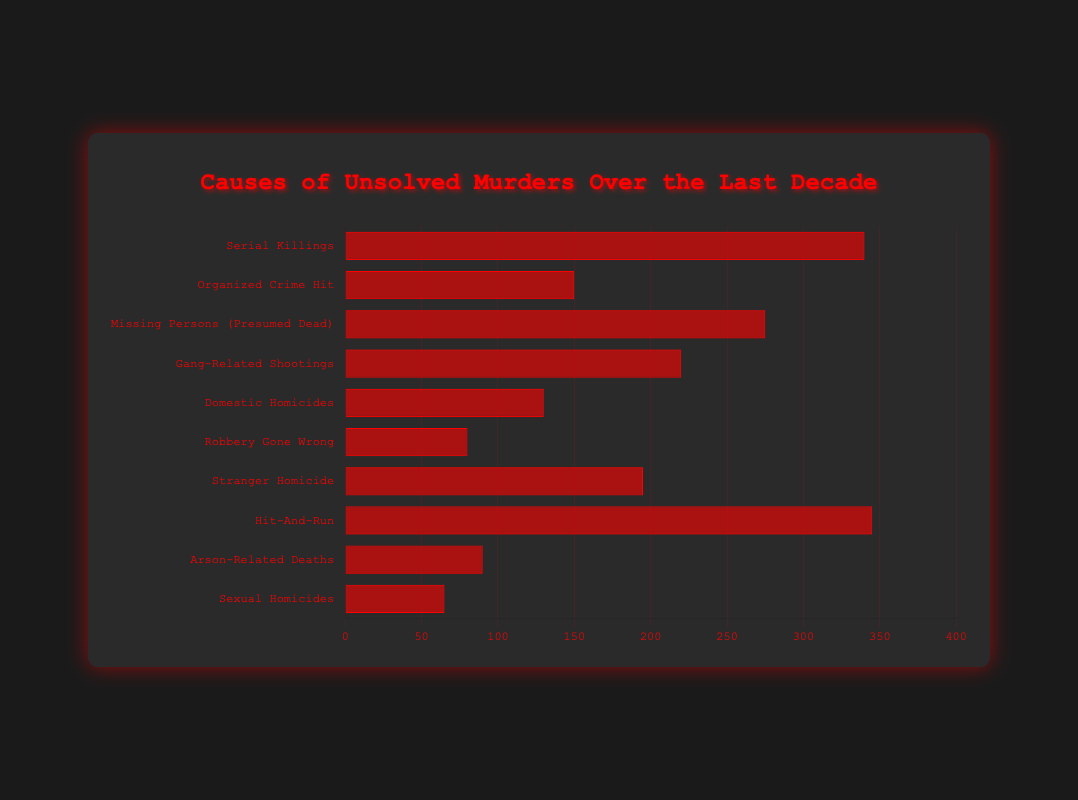What's the most common type of crime for unsolved murder cases? The longest bar in the chart corresponds to Hit-And-Run cases, and since the chart orders the crimes by the number of unsolved cases, it's easy to see that Hit-And-Run has the highest number of unsolved cases at 345.
Answer: Hit-And-Run Which type of crime has fewer unsolved cases: Gang-Related Shootings or Stranger Homicide? Comparing the lengths of the bars, Gang-Related Shootings have 220 unsolved cases, while Stranger Homicide has 195 unsolved cases. Therefore, Stranger Homicide has fewer unsolved cases.
Answer: Stranger Homicide What is the total number of unsolved cases for Organised Crime Hit and Domestic Homicides combined? Add the unsolved cases for Organised Crime Hit (150) and Domestic Homicides (130). Therefore, the total is 150 + 130 = 280.
Answer: 280 Which has a higher number of unsolved cases: Sexual Homicides or Robbery Gone Wrong? By comparing the bars for Sexual Homicides (65 unsolved cases) and Robbery Gone Wrong (80 unsolved cases), Robbery Gone Wrong has a higher number of unsolved cases.
Answer: Robbery Gone Wrong Among Serial Killings, Missing Persons (Presumed Dead), and Arson-Related Deaths, which category has the second-highest number of unsolved cases? First, note the unsolved cases: Serial Killings (340), Missing Persons (Presumed Dead) (275), Arson-Related Deaths (90). The second highest among these is Missing Persons (Presumed Dead).
Answer: Missing Persons (Presumed Dead) What is the sum of the unsolved cases for crimes related to 'homicides' in their category name? The categories are Domestic Homicides (130), Stranger Homicide (195), and Sexual Homicides (65). Add them up: 130 + 195 + 65 = 390.
Answer: 390 What's the difference in the number of unsolved cases between the most common and least common crime types? The most common (Hit-And-Run) has 345 unsolved cases, and the least common (Sexual Homicides) has 65. The difference is 345 - 65 = 280.
Answer: 280 Which types of crime have fewer than 100 unsolved cases? The bars that represent fewer than 100 cases are for Robbery Gone Wrong (80) and Sexual Homicides (65).
Answer: Robbery Gone Wrong, Sexual Homicides How many types of crime have more than 200 unsolved cases? The number of categories with bars extending beyond 200 unsolved cases includes Serial Killings (340), Missing Persons (Presumed Dead) (275), Gang-Related Shootings (220), and Hit-And-Run (345), which totals to 4 types.
Answer: 4 